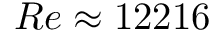Convert formula to latex. <formula><loc_0><loc_0><loc_500><loc_500>R e \approx 1 2 2 1 6</formula> 